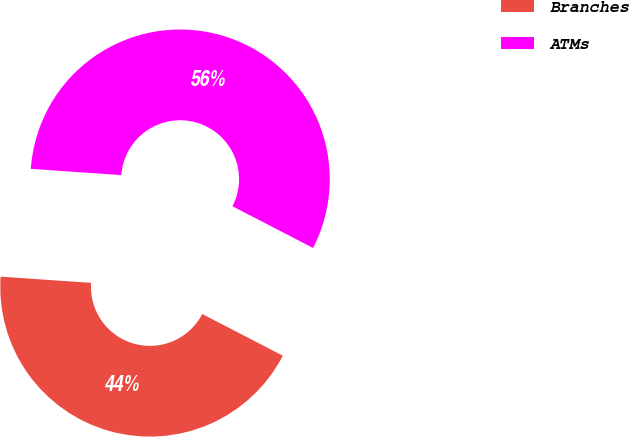Convert chart to OTSL. <chart><loc_0><loc_0><loc_500><loc_500><pie_chart><fcel>Branches<fcel>ATMs<nl><fcel>43.5%<fcel>56.5%<nl></chart> 